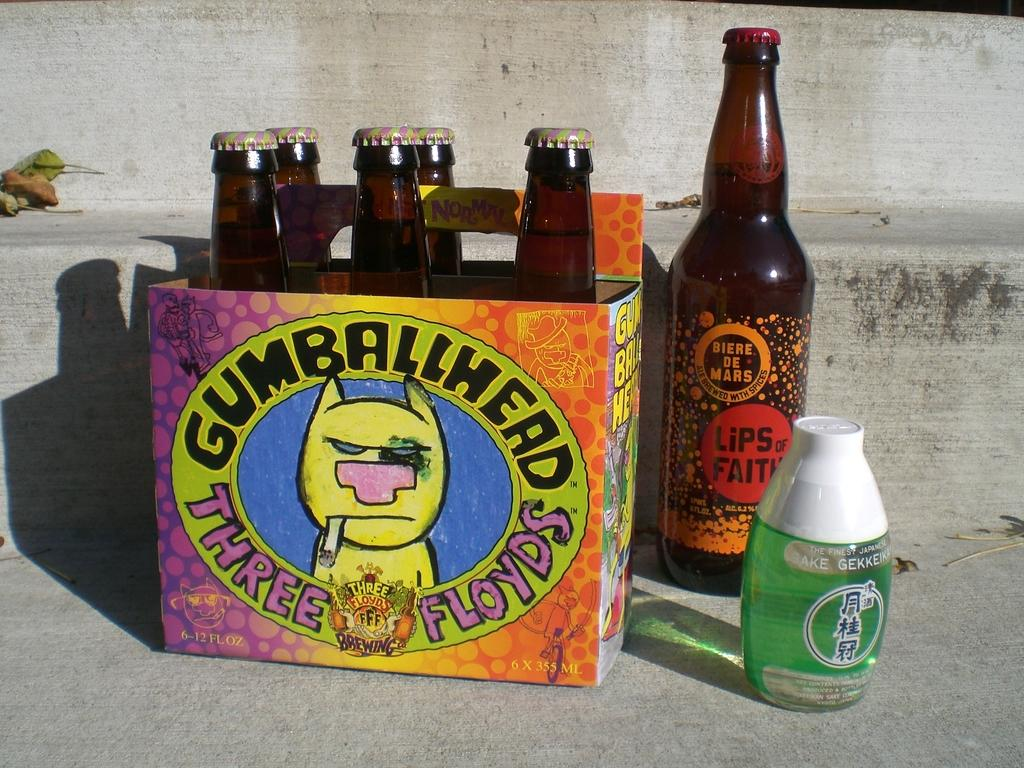What objects are present in the image? There are bottles and a cardboard box in the image. What can be seen in the background of the image? There are leaves and a concrete structure in the background of the image. What hobbies are represented by the bottles in the image? The image does not provide any information about hobbies related to the bottles. --- Facts: 1. There is a person sitting on a chair in the image. 2. The person is holding a book. 3. There is a table next to the chair. 4. There is a lamp on the table. 5. The background of the image is a wall. Absurd Topics: dance, ocean, sculpture Conversation: What is the person in the image doing? The person is sitting on a chair in the image. What is the person holding in the image? The person is holding a book in the image. What is located next to the chair in the image? There is a table next to the chair in the image. What is on the table in the image? There is a lamp on the table in the image. What can be seen behind the person in the image? The background of the image is a wall. Reasoning: Let's think step by step in order to produce the conversation. We start by identifying the main subject in the image, which is the person sitting on a chair. Then, we expand the conversation to include the book the person is holding, the table next to the chair, the lamp on the table, and the wall in the background. Each question is designed to elicit a specific detail about the image that is known from the provided facts. Absurd Question/Answer: Can you describe the ocean waves in the image? There is no ocean or waves present in the image; the background is a wall. 